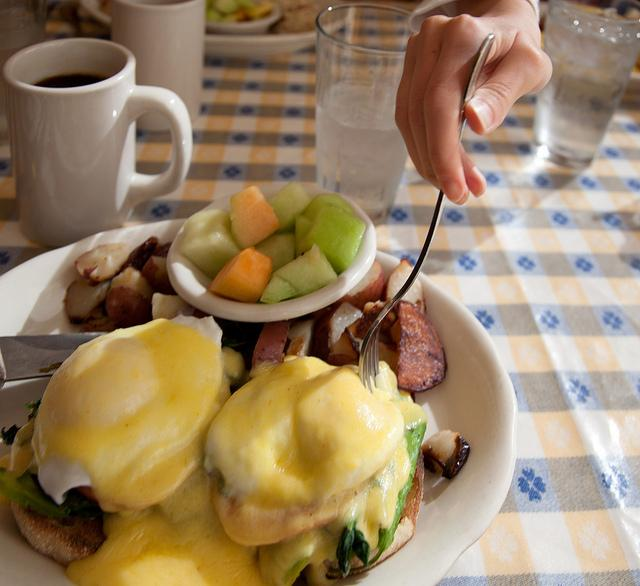What is in the small plate? Please explain your reasoning. cantaloupe. The small plate has green melon pieces, and there's only one readily available green melon. 